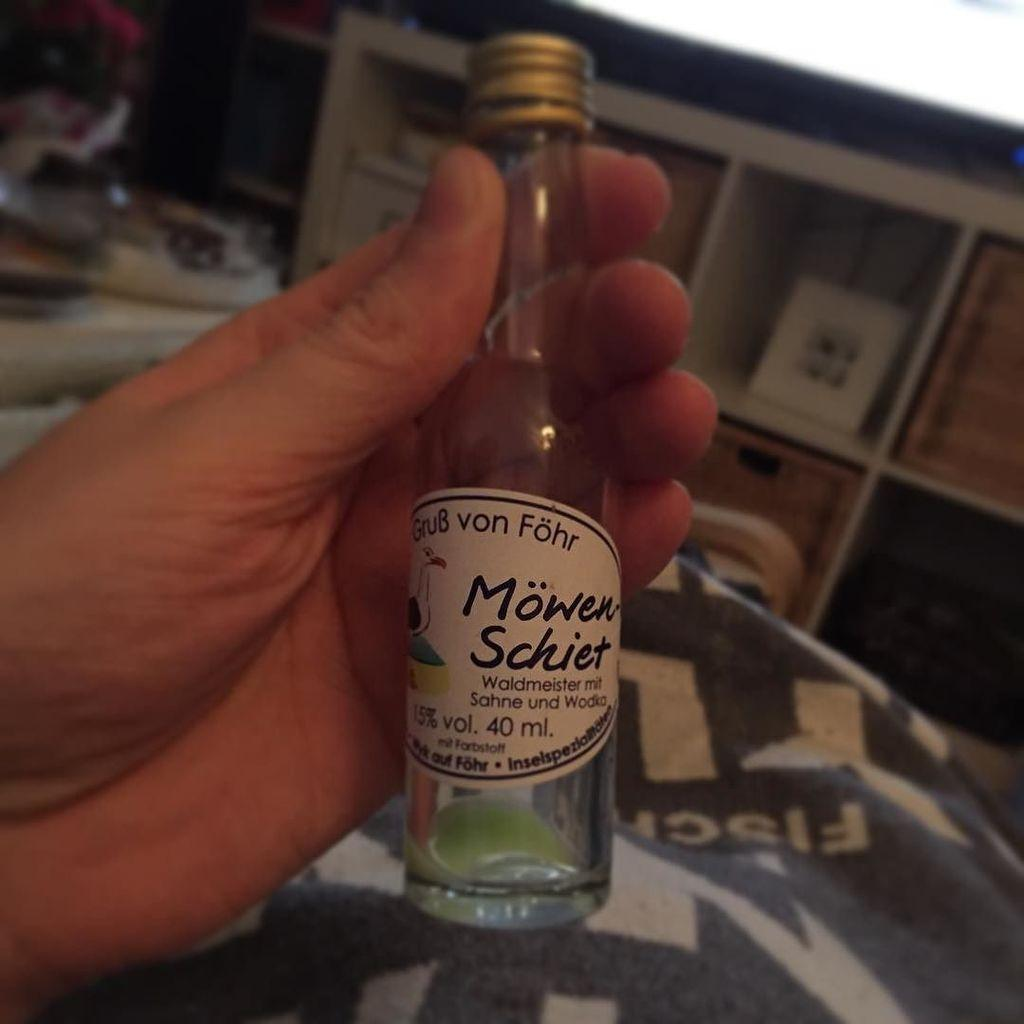What object is being held by a person's hand in the image? There is a bottle in the image, and it is being held by a person's hand. What can be seen in the background of the image? There are racks in the background of the image. How would you describe the background of the image? The background is blurry. What type of pain is the person experiencing while holding the bottle in the image? There is no indication of pain in the image; the person is simply holding a bottle. Can you see a rat in the image? No, there is no rat present in the image. 